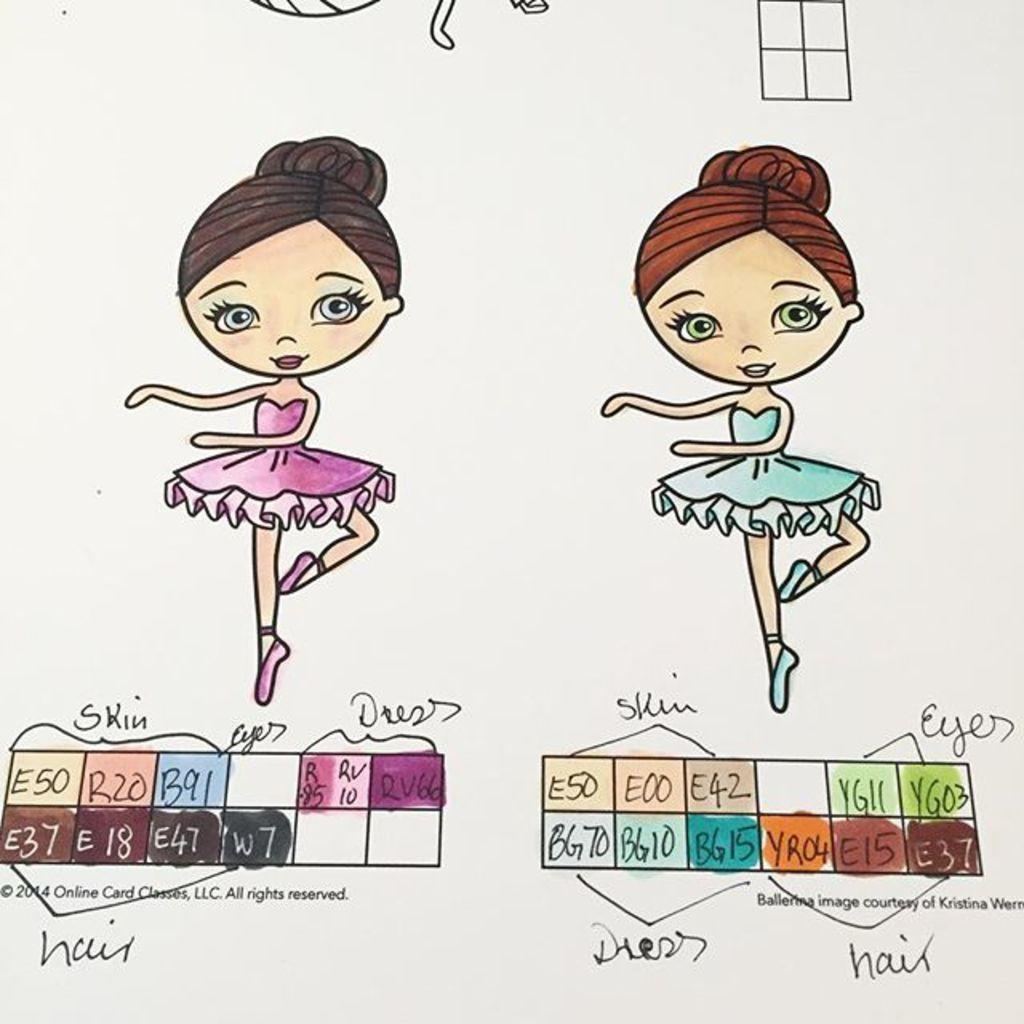What type of artwork is the image? The image is a painting. Who or what is depicted in the painting? There are ladies depicted in the painting. Are there any words or letters in the painting? Yes, there is text present in the painting. Can you identify any numerical elements in the painting? Yes, there are numbers visible in the painting. What color is the kite being flown by one of the ladies in the painting? There is no kite present in the painting; it only depicts ladies, text, and numbers. Can you describe the vein pattern on the hand of one of the ladies in the painting? The painting does not show the vein pattern on the ladies' hands; it only depicts their overall appearance. 